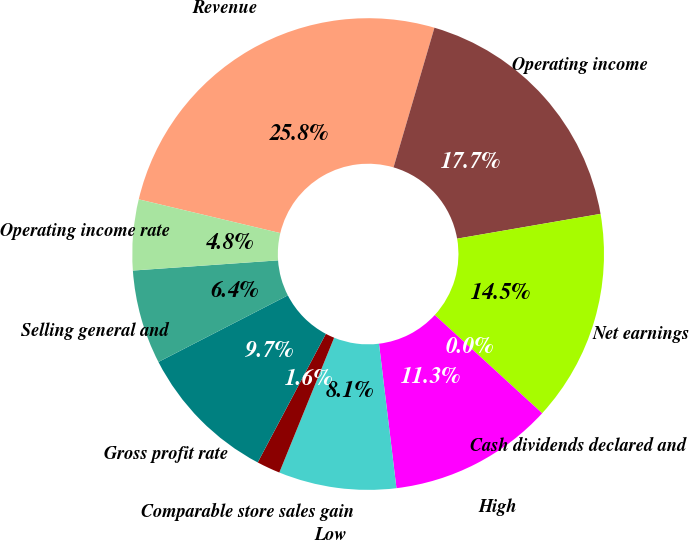Convert chart. <chart><loc_0><loc_0><loc_500><loc_500><pie_chart><fcel>Revenue<fcel>Operating income<fcel>Net earnings<fcel>Cash dividends declared and<fcel>High<fcel>Low<fcel>Comparable store sales gain<fcel>Gross profit rate<fcel>Selling general and<fcel>Operating income rate<nl><fcel>25.81%<fcel>17.74%<fcel>14.52%<fcel>0.0%<fcel>11.29%<fcel>8.06%<fcel>1.61%<fcel>9.68%<fcel>6.45%<fcel>4.84%<nl></chart> 